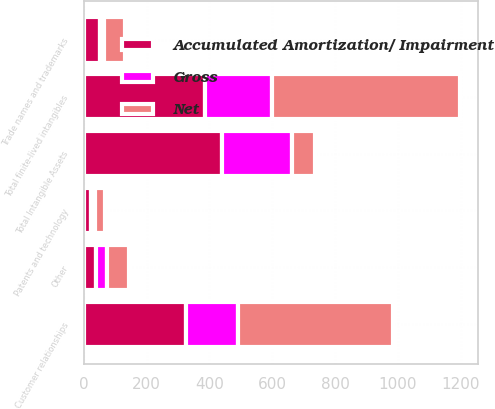<chart> <loc_0><loc_0><loc_500><loc_500><stacked_bar_chart><ecel><fcel>Customer relationships<fcel>Patents and technology<fcel>Other<fcel>Total finite-lived intangibles<fcel>Trade names and trademarks<fcel>Total Intangible Assets<nl><fcel>Net<fcel>491.9<fcel>34<fcel>72.6<fcel>598.5<fcel>64.8<fcel>72.6<nl><fcel>Gross<fcel>165.5<fcel>11.9<fcel>33.8<fcel>211.2<fcel>13.6<fcel>224.8<nl><fcel>Accumulated Amortization/ Impairment<fcel>326.4<fcel>22.1<fcel>38.8<fcel>387.3<fcel>51.2<fcel>438.5<nl></chart> 